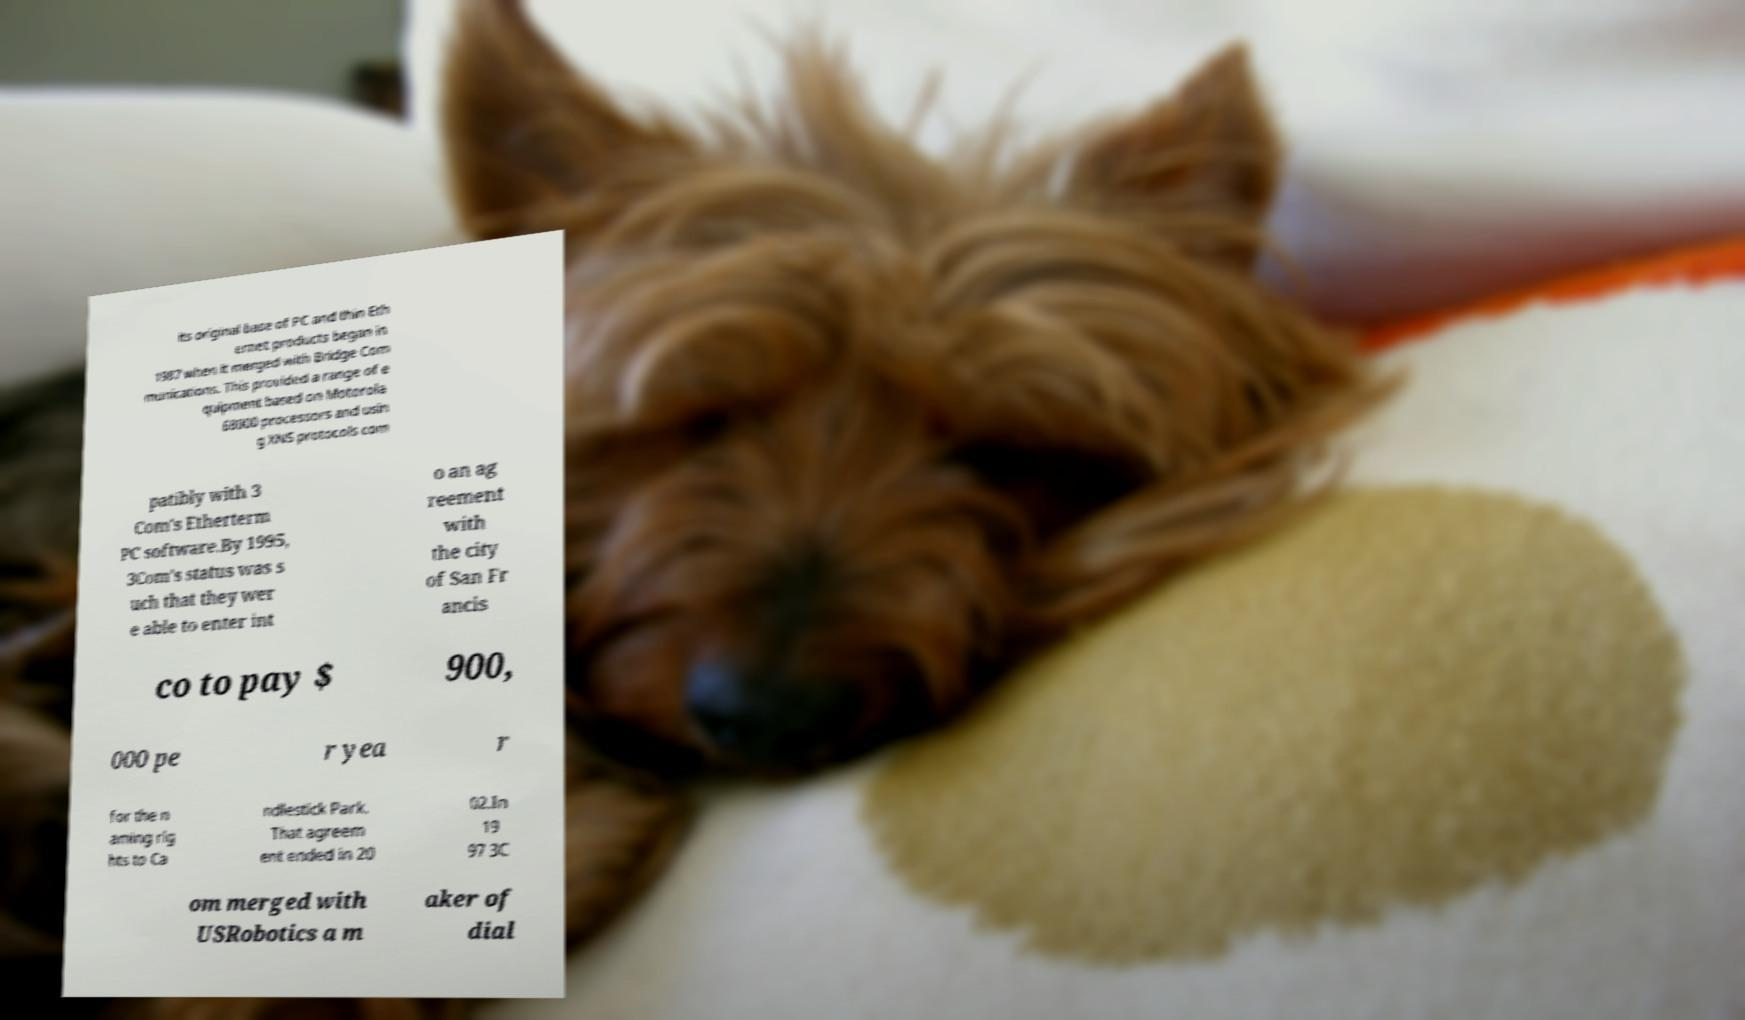There's text embedded in this image that I need extracted. Can you transcribe it verbatim? its original base of PC and thin Eth ernet products began in 1987 when it merged with Bridge Com munications. This provided a range of e quipment based on Motorola 68000 processors and usin g XNS protocols com patibly with 3 Com's Etherterm PC software.By 1995, 3Com's status was s uch that they wer e able to enter int o an ag reement with the city of San Fr ancis co to pay $ 900, 000 pe r yea r for the n aming rig hts to Ca ndlestick Park. That agreem ent ended in 20 02.In 19 97 3C om merged with USRobotics a m aker of dial 